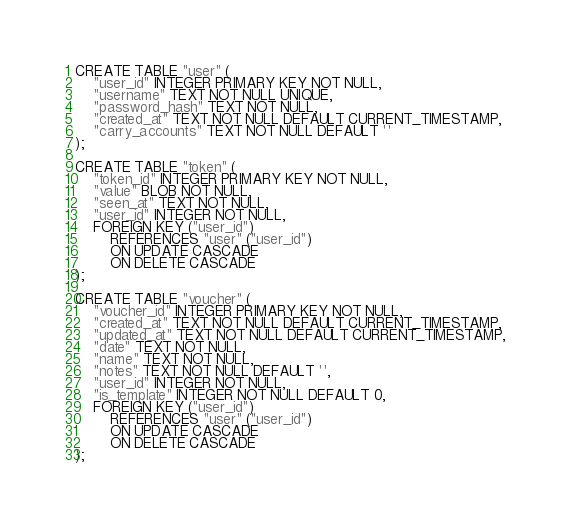<code> <loc_0><loc_0><loc_500><loc_500><_SQL_>CREATE TABLE "user" (
    "user_id" INTEGER PRIMARY KEY NOT NULL,
    "username" TEXT NOT NULL UNIQUE,
    "password_hash" TEXT NOT NULL,
    "created_at" TEXT NOT NULL DEFAULT CURRENT_TIMESTAMP,
    "carry_accounts" TEXT NOT NULL DEFAULT ''
);

CREATE TABLE "token" (
    "token_id" INTEGER PRIMARY KEY NOT NULL,
    "value" BLOB NOT NULL,
    "seen_at" TEXT NOT NULL,
    "user_id" INTEGER NOT NULL,
    FOREIGN KEY ("user_id")
        REFERENCES "user" ("user_id")
        ON UPDATE CASCADE
        ON DELETE CASCADE
);

CREATE TABLE "voucher" (
    "voucher_id" INTEGER PRIMARY KEY NOT NULL,
    "created_at" TEXT NOT NULL DEFAULT CURRENT_TIMESTAMP,
    "updated_at" TEXT NOT NULL DEFAULT CURRENT_TIMESTAMP,
    "date" TEXT NOT NULL,
    "name" TEXT NOT NULL,
    "notes" TEXT NOT NULL DEFAULT '',
    "user_id" INTEGER NOT NULL,
    "is_template" INTEGER NOT NULL DEFAULT 0,
    FOREIGN KEY ("user_id")
        REFERENCES "user" ("user_id")
        ON UPDATE CASCADE
        ON DELETE CASCADE
);
</code> 